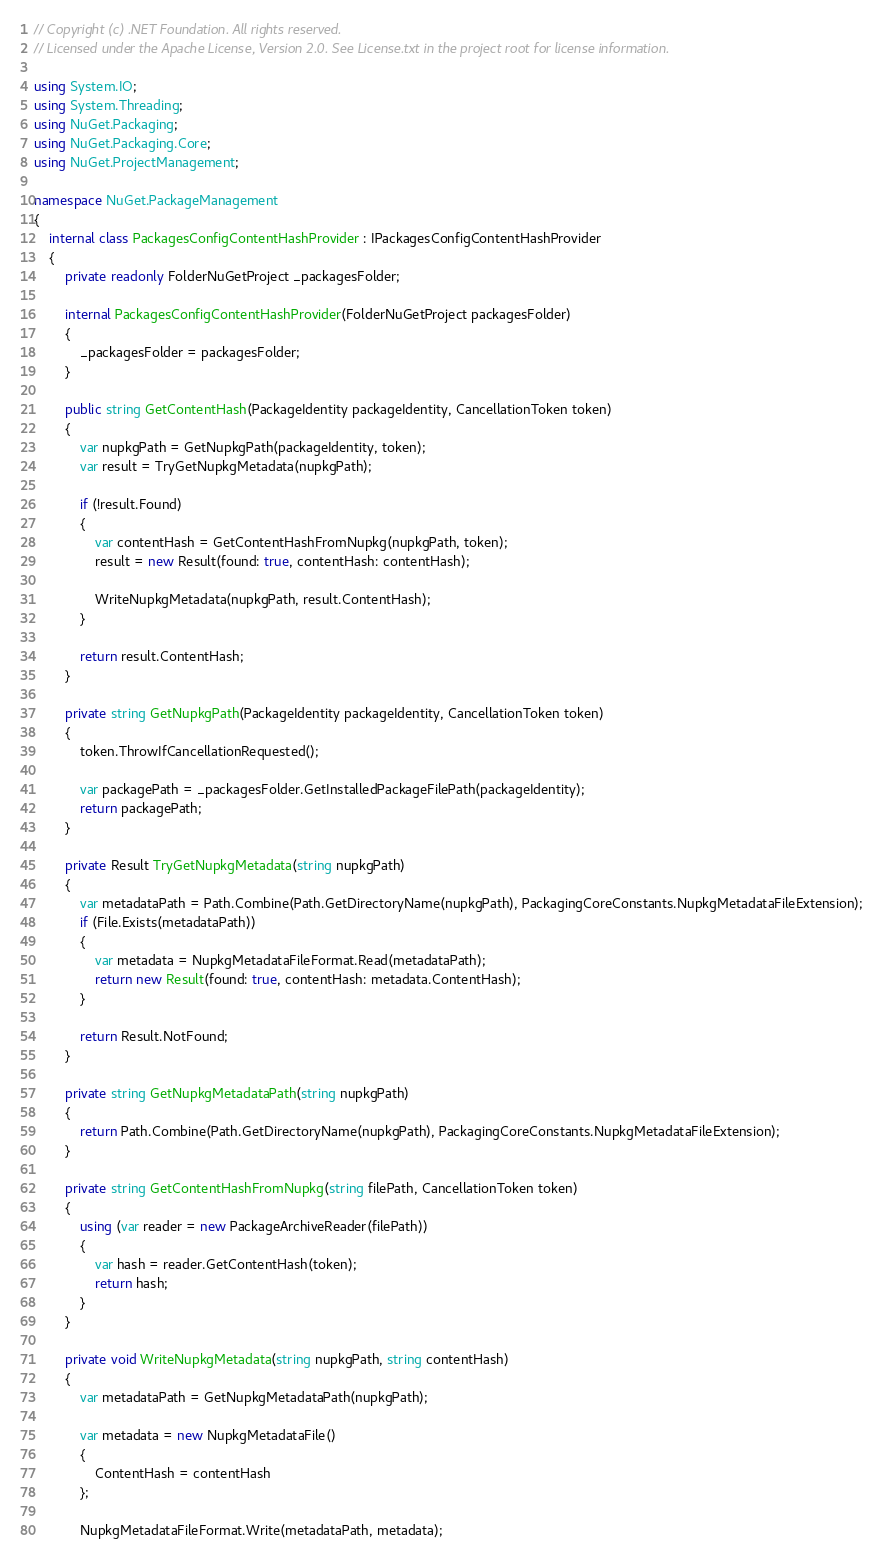Convert code to text. <code><loc_0><loc_0><loc_500><loc_500><_C#_>// Copyright (c) .NET Foundation. All rights reserved.
// Licensed under the Apache License, Version 2.0. See License.txt in the project root for license information.

using System.IO;
using System.Threading;
using NuGet.Packaging;
using NuGet.Packaging.Core;
using NuGet.ProjectManagement;

namespace NuGet.PackageManagement
{
    internal class PackagesConfigContentHashProvider : IPackagesConfigContentHashProvider
    {
        private readonly FolderNuGetProject _packagesFolder;

        internal PackagesConfigContentHashProvider(FolderNuGetProject packagesFolder)
        {
            _packagesFolder = packagesFolder;
        }

        public string GetContentHash(PackageIdentity packageIdentity, CancellationToken token)
        {
            var nupkgPath = GetNupkgPath(packageIdentity, token);
            var result = TryGetNupkgMetadata(nupkgPath);

            if (!result.Found)
            {
                var contentHash = GetContentHashFromNupkg(nupkgPath, token);
                result = new Result(found: true, contentHash: contentHash);

                WriteNupkgMetadata(nupkgPath, result.ContentHash);
            }

            return result.ContentHash;
        }

        private string GetNupkgPath(PackageIdentity packageIdentity, CancellationToken token)
        {
            token.ThrowIfCancellationRequested();

            var packagePath = _packagesFolder.GetInstalledPackageFilePath(packageIdentity);
            return packagePath;
        }

        private Result TryGetNupkgMetadata(string nupkgPath)
        {
            var metadataPath = Path.Combine(Path.GetDirectoryName(nupkgPath), PackagingCoreConstants.NupkgMetadataFileExtension);
            if (File.Exists(metadataPath))
            {
                var metadata = NupkgMetadataFileFormat.Read(metadataPath);
                return new Result(found: true, contentHash: metadata.ContentHash);
            }

            return Result.NotFound;
        }

        private string GetNupkgMetadataPath(string nupkgPath)
        {
            return Path.Combine(Path.GetDirectoryName(nupkgPath), PackagingCoreConstants.NupkgMetadataFileExtension);
        }

        private string GetContentHashFromNupkg(string filePath, CancellationToken token)
        {
            using (var reader = new PackageArchiveReader(filePath))
            {
                var hash = reader.GetContentHash(token);
                return hash;
            }
        }

        private void WriteNupkgMetadata(string nupkgPath, string contentHash)
        {
            var metadataPath = GetNupkgMetadataPath(nupkgPath);

            var metadata = new NupkgMetadataFile()
            {
                ContentHash = contentHash
            };

            NupkgMetadataFileFormat.Write(metadataPath, metadata);</code> 